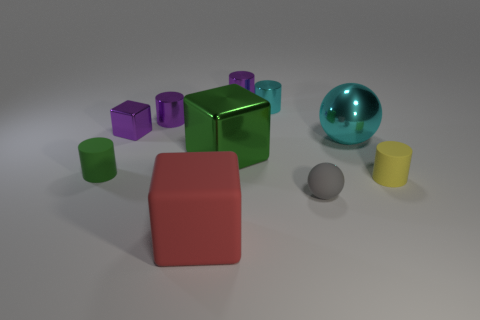Subtract all green shiny blocks. How many blocks are left? 2 Subtract all blue cubes. How many purple cylinders are left? 2 Subtract all green cylinders. How many cylinders are left? 4 Subtract 3 cylinders. How many cylinders are left? 2 Subtract all blue cubes. Subtract all brown spheres. How many cubes are left? 3 Subtract all blocks. How many objects are left? 7 Subtract all tiny cyan metallic cylinders. Subtract all small purple metallic things. How many objects are left? 6 Add 5 matte things. How many matte things are left? 9 Add 6 green cylinders. How many green cylinders exist? 7 Subtract 1 green cylinders. How many objects are left? 9 